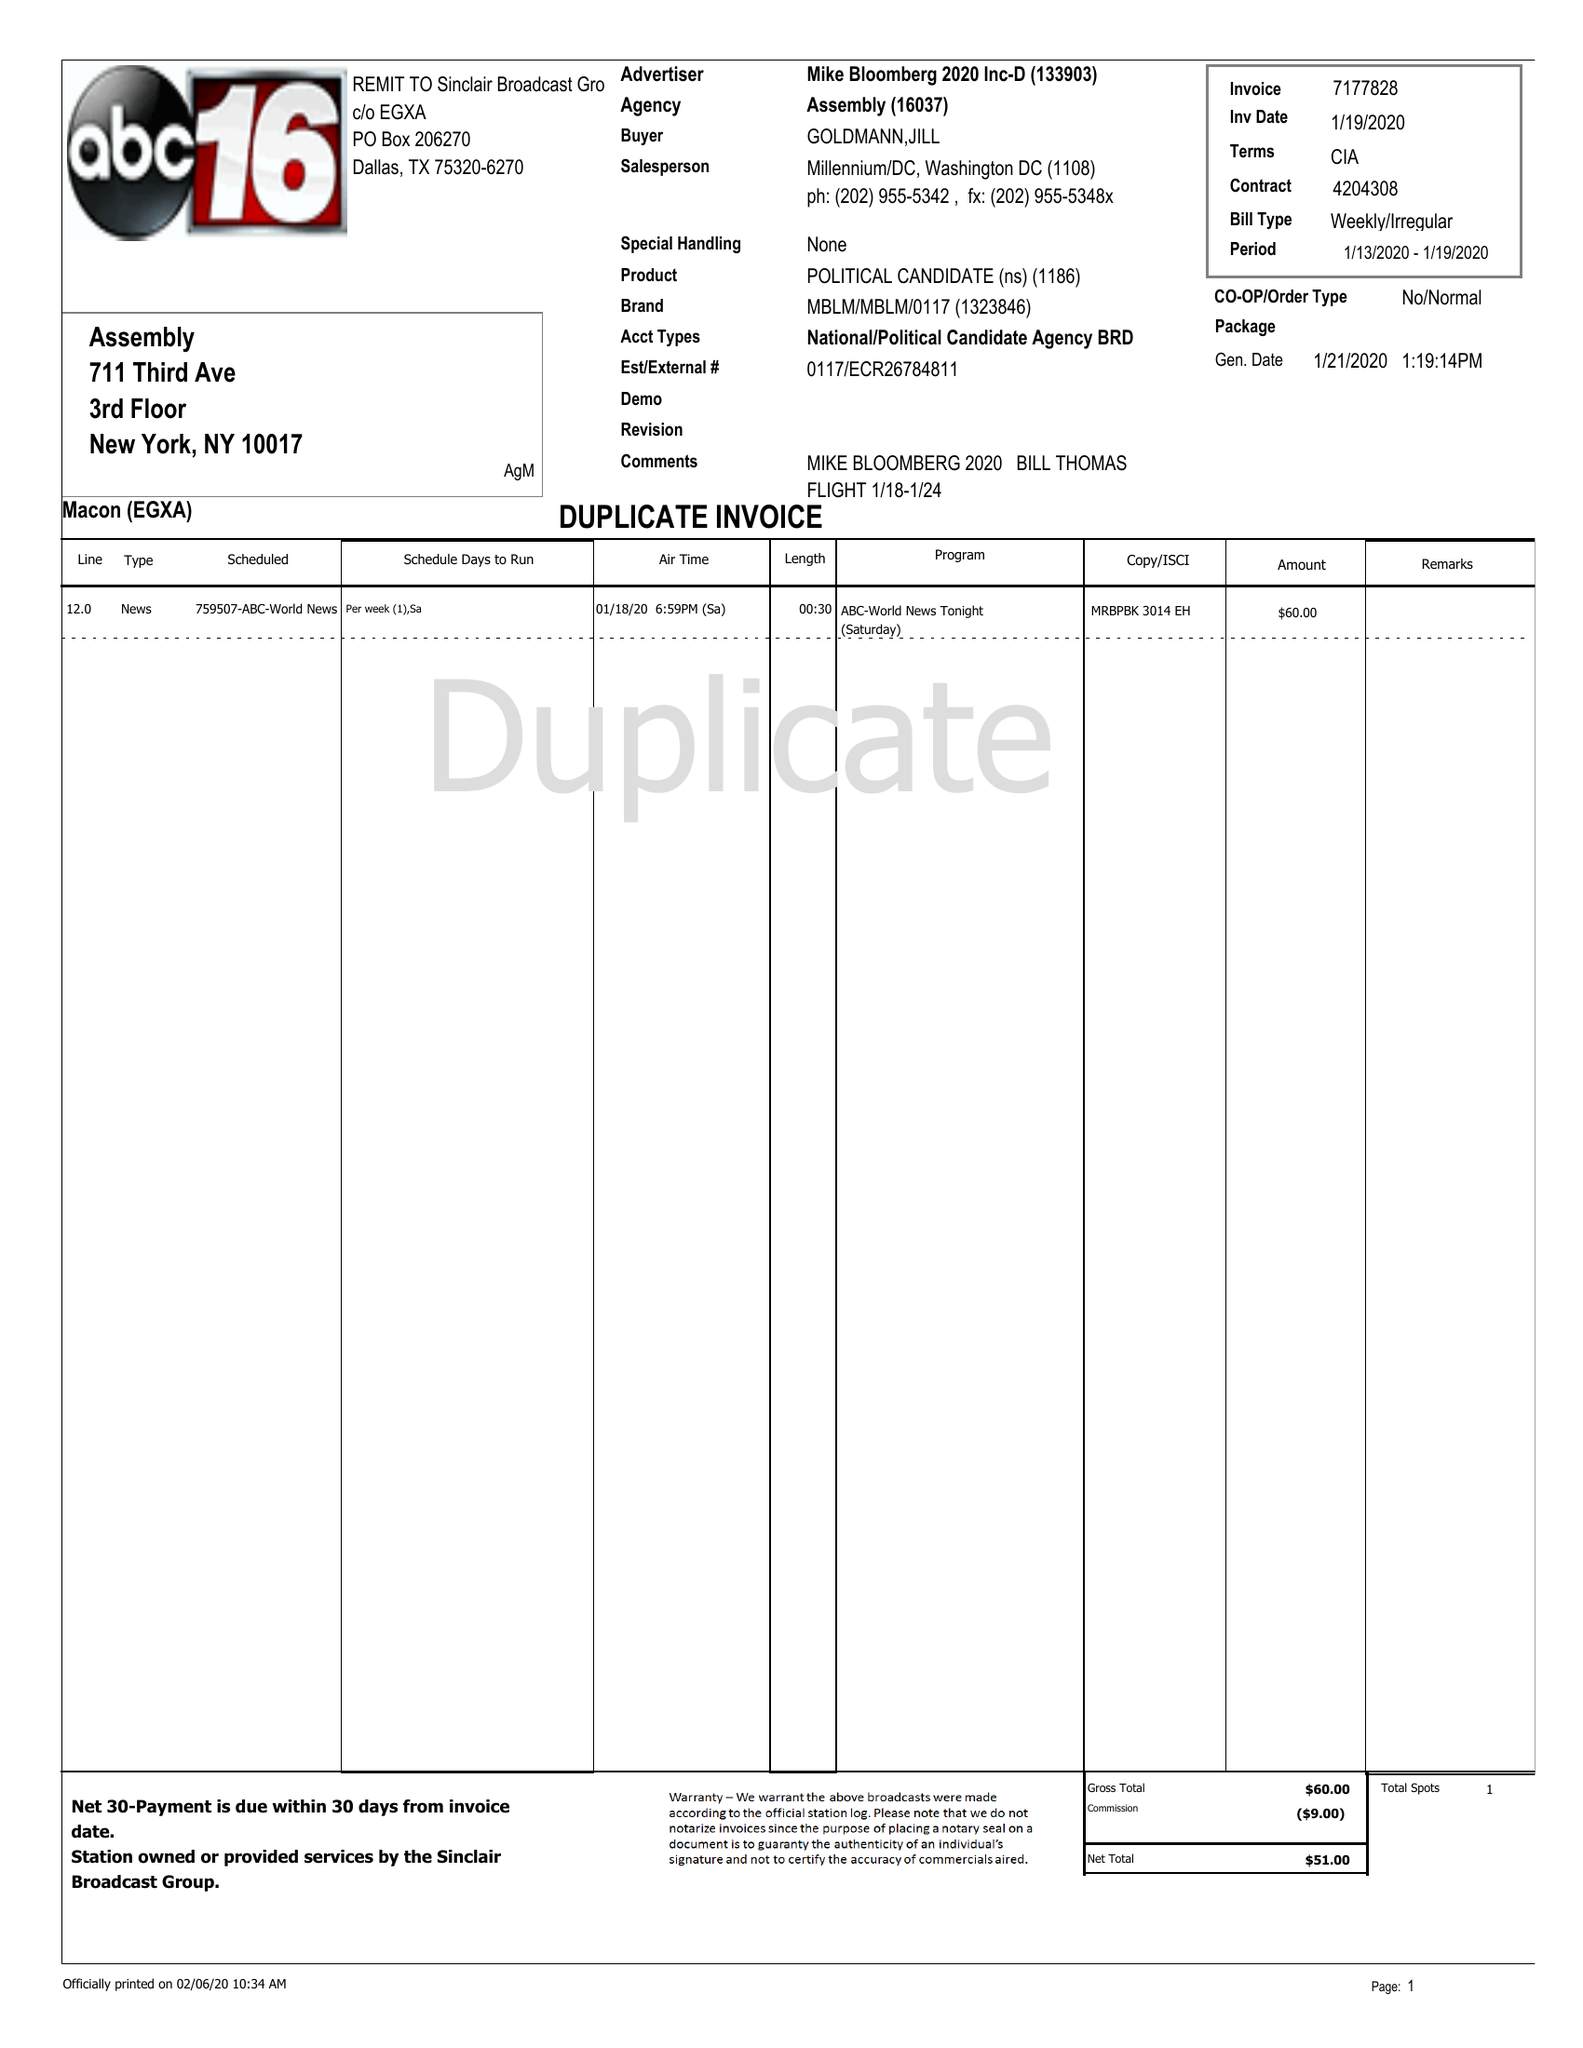What is the value for the contract_num?
Answer the question using a single word or phrase. 4204308 